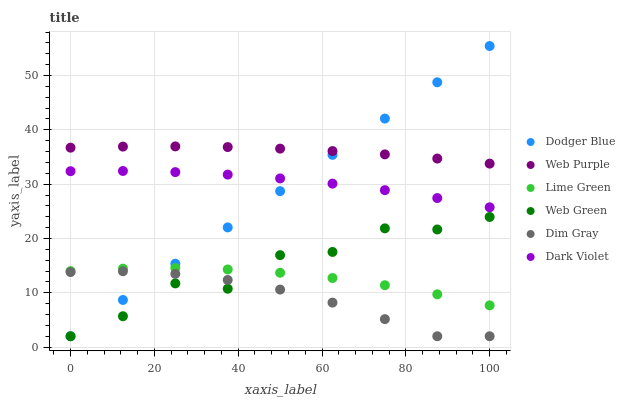Does Dim Gray have the minimum area under the curve?
Answer yes or no. Yes. Does Web Purple have the maximum area under the curve?
Answer yes or no. Yes. Does Dark Violet have the minimum area under the curve?
Answer yes or no. No. Does Dark Violet have the maximum area under the curve?
Answer yes or no. No. Is Dodger Blue the smoothest?
Answer yes or no. Yes. Is Web Green the roughest?
Answer yes or no. Yes. Is Dark Violet the smoothest?
Answer yes or no. No. Is Dark Violet the roughest?
Answer yes or no. No. Does Dim Gray have the lowest value?
Answer yes or no. Yes. Does Dark Violet have the lowest value?
Answer yes or no. No. Does Dodger Blue have the highest value?
Answer yes or no. Yes. Does Dark Violet have the highest value?
Answer yes or no. No. Is Dim Gray less than Web Purple?
Answer yes or no. Yes. Is Web Purple greater than Dim Gray?
Answer yes or no. Yes. Does Dark Violet intersect Dodger Blue?
Answer yes or no. Yes. Is Dark Violet less than Dodger Blue?
Answer yes or no. No. Is Dark Violet greater than Dodger Blue?
Answer yes or no. No. Does Dim Gray intersect Web Purple?
Answer yes or no. No. 